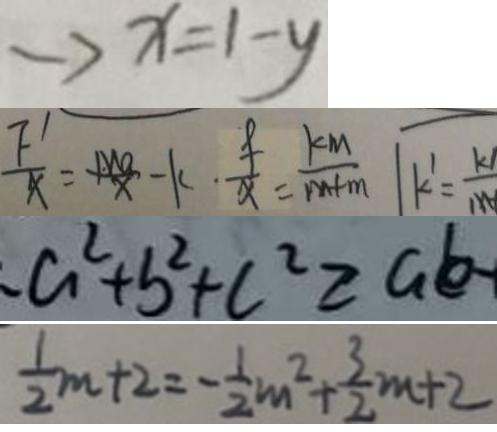Convert formula to latex. <formula><loc_0><loc_0><loc_500><loc_500>\rightarrow x = 1 - y 
 \frac { F ^ { \prime } } { x } = \frac { M a } { x } - k \cdot \frac { f } { x } = \frac { k M } { m + n } 
 a ^ { 2 } + b ^ { 2 } + c ^ { 2 } \geq a b - 
 \frac { 1 } { 2 } m + 2 = - \frac { 1 } { 2 } m ^ { 2 } + \frac { 3 } { 2 } m + 2</formula> 